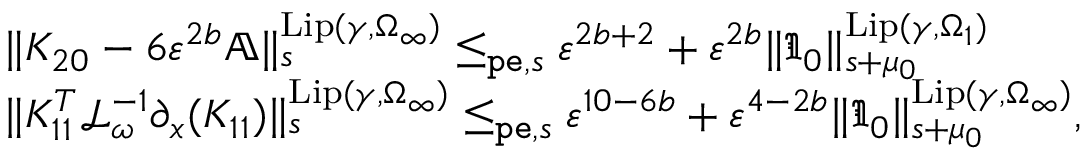Convert formula to latex. <formula><loc_0><loc_0><loc_500><loc_500>\begin{array} { r l } & { \| K _ { 2 0 } - 6 \varepsilon ^ { 2 b } \mathbb { A } \| _ { s } ^ { L i p ( \gamma , \Omega _ { \infty } ) } \leq _ { p e , s } \varepsilon ^ { 2 b + 2 } + \varepsilon ^ { 2 b } \| \mathfrak { I } _ { 0 } \| _ { s + \mu _ { 0 } } ^ { L i p ( \gamma , \Omega _ { 1 } ) } } \\ & { \| K _ { 1 1 } ^ { T } \mathcal { L } _ { \omega } ^ { - 1 } \partial _ { x } ( K _ { 1 1 } ) \| _ { s } ^ { L i p ( \gamma , \Omega _ { \infty } ) } \leq _ { p e , s } \varepsilon ^ { 1 0 - 6 b } + \varepsilon ^ { 4 - 2 b } \| \mathfrak { I } _ { 0 } \| _ { s + \mu _ { 0 } } ^ { L i p ( \gamma , \Omega _ { \infty } ) } , } \end{array}</formula> 